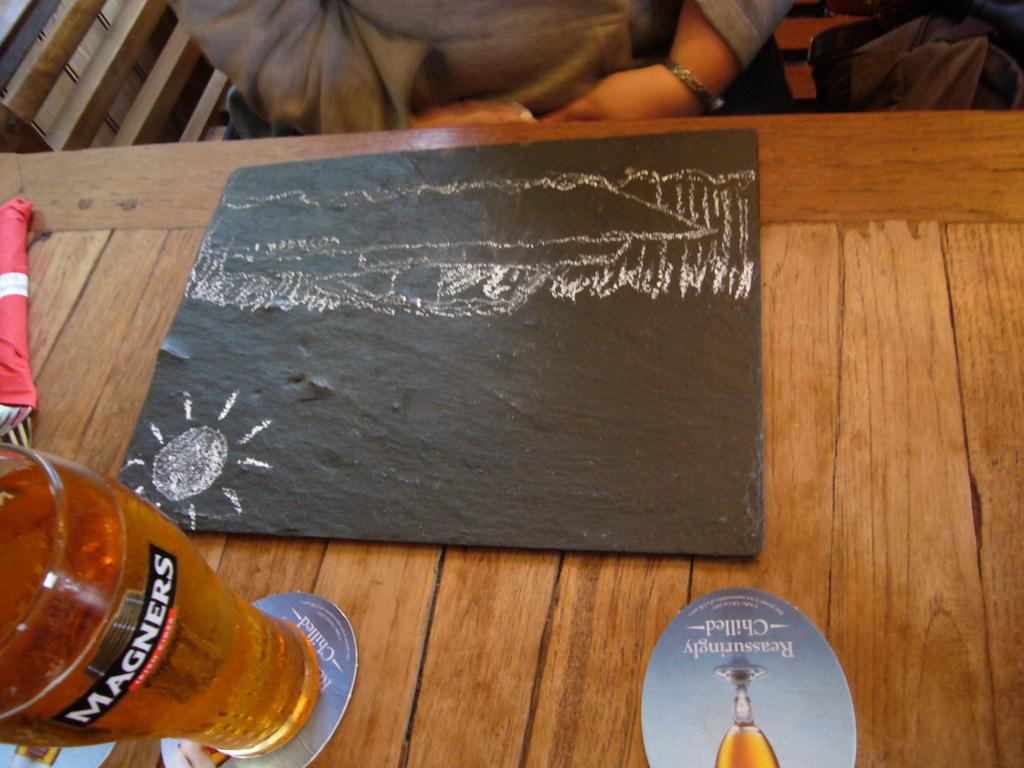What brand is on the glass?
Offer a very short reply. Magners. What is this?
Your answer should be very brief. Answering does not require reading text in the image. 